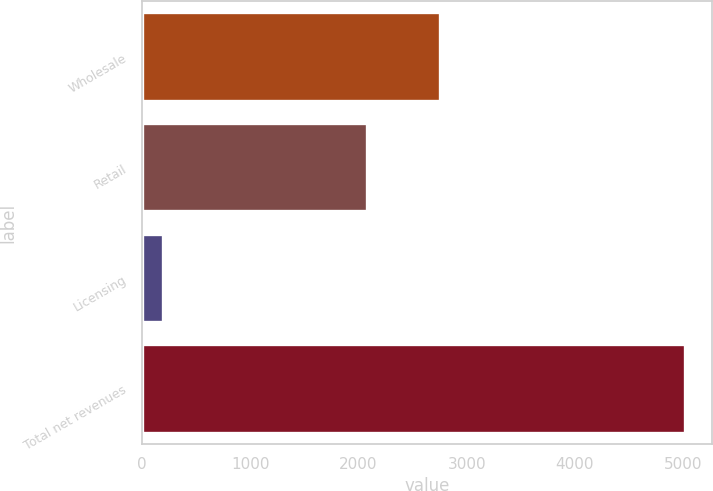<chart> <loc_0><loc_0><loc_500><loc_500><bar_chart><fcel>Wholesale<fcel>Retail<fcel>Licensing<fcel>Total net revenues<nl><fcel>2749.5<fcel>2074.2<fcel>195.2<fcel>5018.9<nl></chart> 